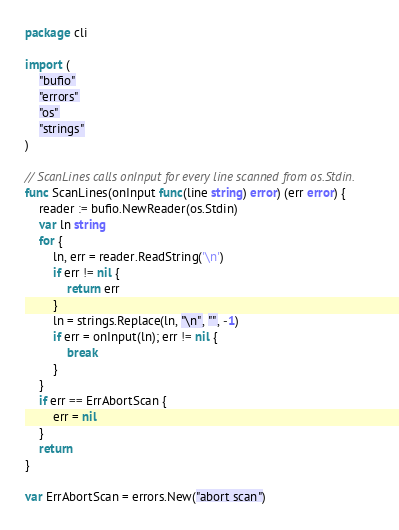<code> <loc_0><loc_0><loc_500><loc_500><_Go_>package cli

import (
	"bufio"
	"errors"
	"os"
	"strings"
)

// ScanLines calls onInput for every line scanned from os.Stdin.
func ScanLines(onInput func(line string) error) (err error) {
	reader := bufio.NewReader(os.Stdin)
	var ln string
	for {
		ln, err = reader.ReadString('\n')
		if err != nil {
			return err
		}
		ln = strings.Replace(ln, "\n", "", -1)
		if err = onInput(ln); err != nil {
			break
		}
	}
	if err == ErrAbortScan {
		err = nil
	}
	return
}

var ErrAbortScan = errors.New("abort scan")
</code> 